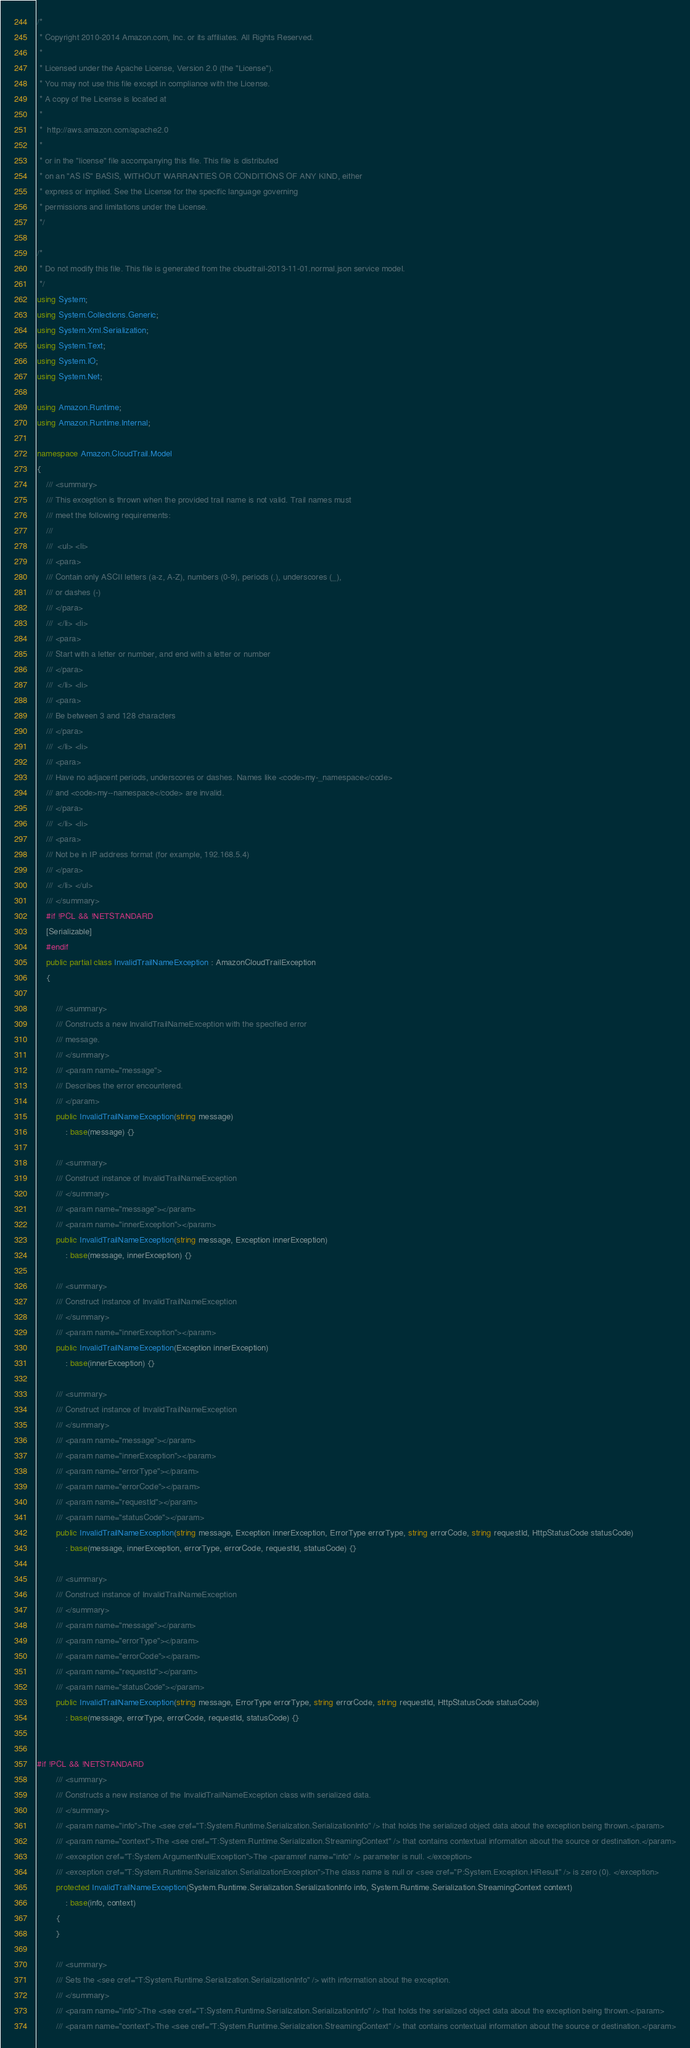<code> <loc_0><loc_0><loc_500><loc_500><_C#_>/*
 * Copyright 2010-2014 Amazon.com, Inc. or its affiliates. All Rights Reserved.
 * 
 * Licensed under the Apache License, Version 2.0 (the "License").
 * You may not use this file except in compliance with the License.
 * A copy of the License is located at
 * 
 *  http://aws.amazon.com/apache2.0
 * 
 * or in the "license" file accompanying this file. This file is distributed
 * on an "AS IS" BASIS, WITHOUT WARRANTIES OR CONDITIONS OF ANY KIND, either
 * express or implied. See the License for the specific language governing
 * permissions and limitations under the License.
 */

/*
 * Do not modify this file. This file is generated from the cloudtrail-2013-11-01.normal.json service model.
 */
using System;
using System.Collections.Generic;
using System.Xml.Serialization;
using System.Text;
using System.IO;
using System.Net;

using Amazon.Runtime;
using Amazon.Runtime.Internal;

namespace Amazon.CloudTrail.Model
{
    /// <summary>
    /// This exception is thrown when the provided trail name is not valid. Trail names must
    /// meet the following requirements:
    /// 
    ///  <ul> <li> 
    /// <para>
    /// Contain only ASCII letters (a-z, A-Z), numbers (0-9), periods (.), underscores (_),
    /// or dashes (-)
    /// </para>
    ///  </li> <li> 
    /// <para>
    /// Start with a letter or number, and end with a letter or number
    /// </para>
    ///  </li> <li> 
    /// <para>
    /// Be between 3 and 128 characters
    /// </para>
    ///  </li> <li> 
    /// <para>
    /// Have no adjacent periods, underscores or dashes. Names like <code>my-_namespace</code>
    /// and <code>my--namespace</code> are invalid.
    /// </para>
    ///  </li> <li> 
    /// <para>
    /// Not be in IP address format (for example, 192.168.5.4)
    /// </para>
    ///  </li> </ul>
    /// </summary>
    #if !PCL && !NETSTANDARD
    [Serializable]
    #endif
    public partial class InvalidTrailNameException : AmazonCloudTrailException
    {

        /// <summary>
        /// Constructs a new InvalidTrailNameException with the specified error
        /// message.
        /// </summary>
        /// <param name="message">
        /// Describes the error encountered.
        /// </param>
        public InvalidTrailNameException(string message) 
            : base(message) {}

        /// <summary>
        /// Construct instance of InvalidTrailNameException
        /// </summary>
        /// <param name="message"></param>
        /// <param name="innerException"></param>
        public InvalidTrailNameException(string message, Exception innerException) 
            : base(message, innerException) {}

        /// <summary>
        /// Construct instance of InvalidTrailNameException
        /// </summary>
        /// <param name="innerException"></param>
        public InvalidTrailNameException(Exception innerException) 
            : base(innerException) {}

        /// <summary>
        /// Construct instance of InvalidTrailNameException
        /// </summary>
        /// <param name="message"></param>
        /// <param name="innerException"></param>
        /// <param name="errorType"></param>
        /// <param name="errorCode"></param>
        /// <param name="requestId"></param>
        /// <param name="statusCode"></param>
        public InvalidTrailNameException(string message, Exception innerException, ErrorType errorType, string errorCode, string requestId, HttpStatusCode statusCode) 
            : base(message, innerException, errorType, errorCode, requestId, statusCode) {}

        /// <summary>
        /// Construct instance of InvalidTrailNameException
        /// </summary>
        /// <param name="message"></param>
        /// <param name="errorType"></param>
        /// <param name="errorCode"></param>
        /// <param name="requestId"></param>
        /// <param name="statusCode"></param>
        public InvalidTrailNameException(string message, ErrorType errorType, string errorCode, string requestId, HttpStatusCode statusCode) 
            : base(message, errorType, errorCode, requestId, statusCode) {}


#if !PCL && !NETSTANDARD
        /// <summary>
        /// Constructs a new instance of the InvalidTrailNameException class with serialized data.
        /// </summary>
        /// <param name="info">The <see cref="T:System.Runtime.Serialization.SerializationInfo" /> that holds the serialized object data about the exception being thrown.</param>
        /// <param name="context">The <see cref="T:System.Runtime.Serialization.StreamingContext" /> that contains contextual information about the source or destination.</param>
        /// <exception cref="T:System.ArgumentNullException">The <paramref name="info" /> parameter is null. </exception>
        /// <exception cref="T:System.Runtime.Serialization.SerializationException">The class name is null or <see cref="P:System.Exception.HResult" /> is zero (0). </exception>
        protected InvalidTrailNameException(System.Runtime.Serialization.SerializationInfo info, System.Runtime.Serialization.StreamingContext context)
            : base(info, context)
        {
        }

        /// <summary>
        /// Sets the <see cref="T:System.Runtime.Serialization.SerializationInfo" /> with information about the exception.
        /// </summary>
        /// <param name="info">The <see cref="T:System.Runtime.Serialization.SerializationInfo" /> that holds the serialized object data about the exception being thrown.</param>
        /// <param name="context">The <see cref="T:System.Runtime.Serialization.StreamingContext" /> that contains contextual information about the source or destination.</param></code> 